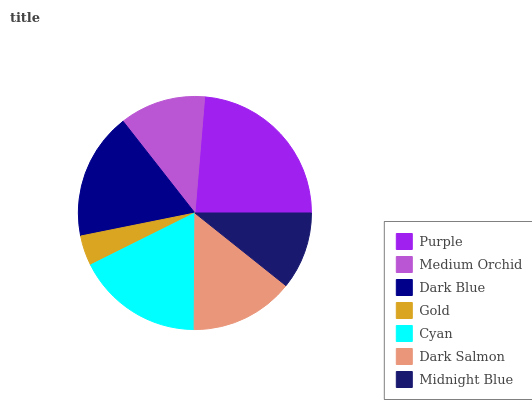Is Gold the minimum?
Answer yes or no. Yes. Is Purple the maximum?
Answer yes or no. Yes. Is Medium Orchid the minimum?
Answer yes or no. No. Is Medium Orchid the maximum?
Answer yes or no. No. Is Purple greater than Medium Orchid?
Answer yes or no. Yes. Is Medium Orchid less than Purple?
Answer yes or no. Yes. Is Medium Orchid greater than Purple?
Answer yes or no. No. Is Purple less than Medium Orchid?
Answer yes or no. No. Is Dark Salmon the high median?
Answer yes or no. Yes. Is Dark Salmon the low median?
Answer yes or no. Yes. Is Gold the high median?
Answer yes or no. No. Is Purple the low median?
Answer yes or no. No. 